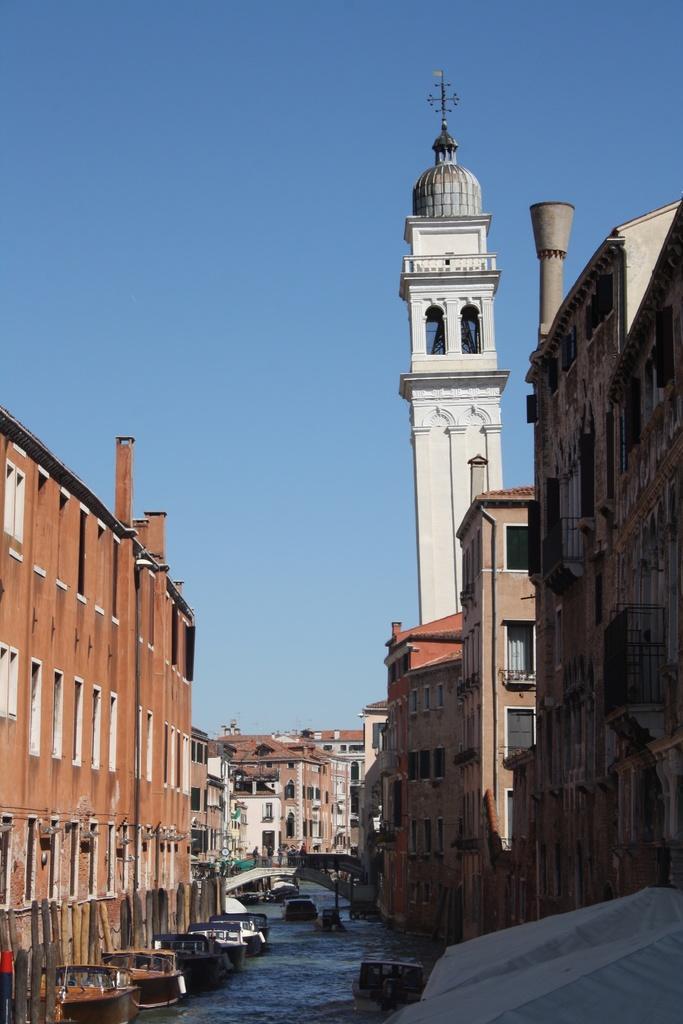In one or two sentences, can you explain what this image depicts? In this image there are buildings. At the bottom there is a canal and we can see boats on the canal. We can see a bridge. In the background there is sky. 